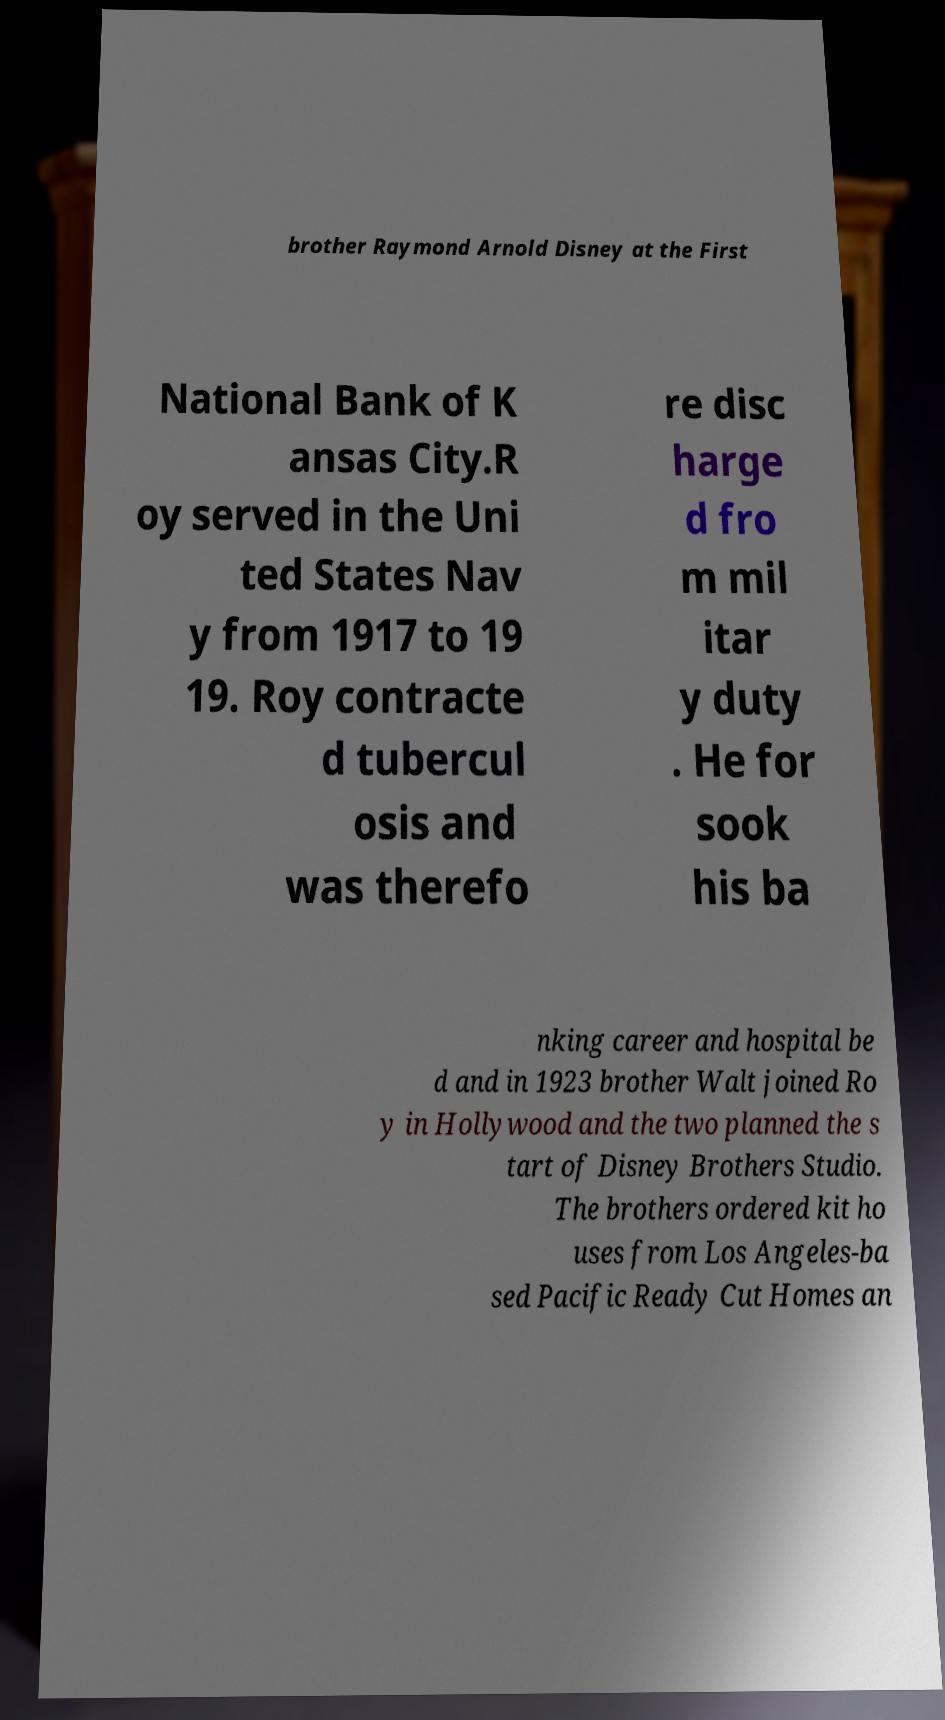Could you assist in decoding the text presented in this image and type it out clearly? brother Raymond Arnold Disney at the First National Bank of K ansas City.R oy served in the Uni ted States Nav y from 1917 to 19 19. Roy contracte d tubercul osis and was therefo re disc harge d fro m mil itar y duty . He for sook his ba nking career and hospital be d and in 1923 brother Walt joined Ro y in Hollywood and the two planned the s tart of Disney Brothers Studio. The brothers ordered kit ho uses from Los Angeles-ba sed Pacific Ready Cut Homes an 